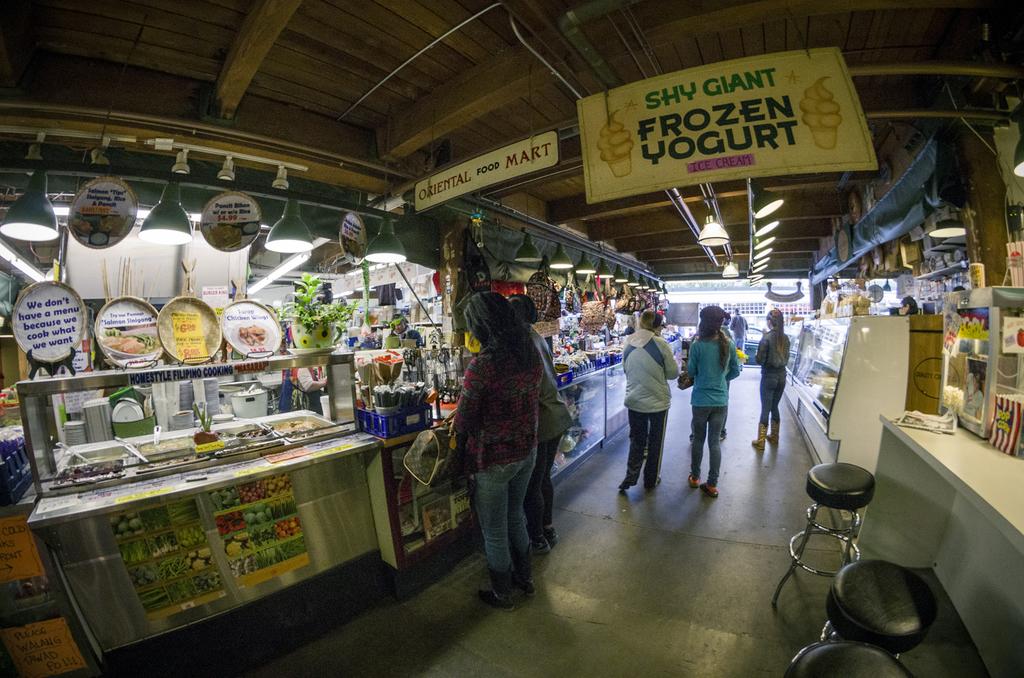What do they sell here?
Give a very brief answer. Frozen yogurt. 